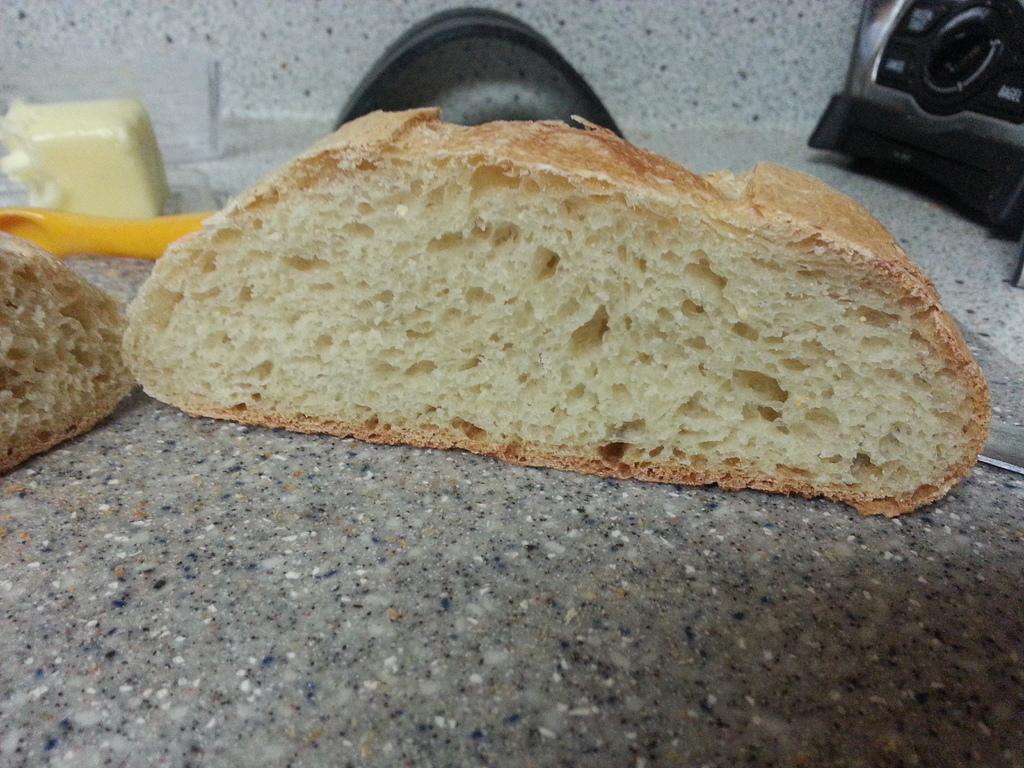Please provide a concise description of this image. In this image I can see the food. To the side I can see the black and yellow color objects. These are on the countertop. 